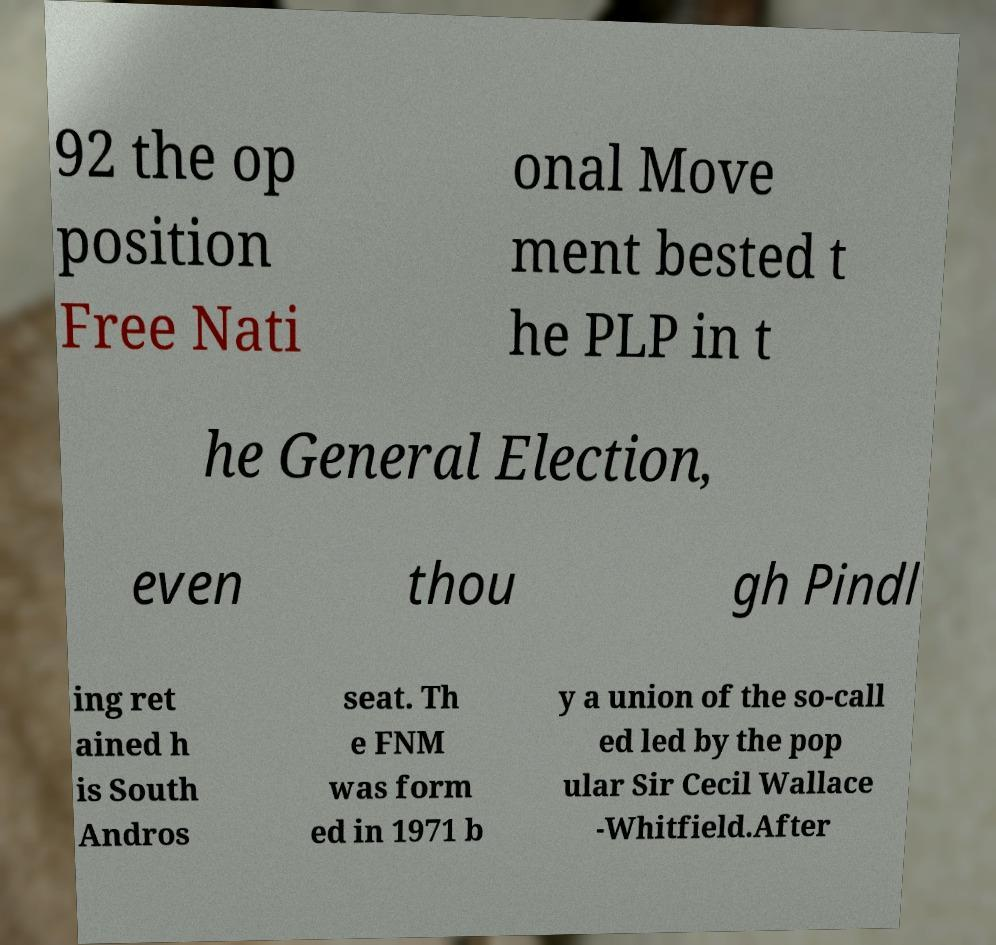Please read and relay the text visible in this image. What does it say? 92 the op position Free Nati onal Move ment bested t he PLP in t he General Election, even thou gh Pindl ing ret ained h is South Andros seat. Th e FNM was form ed in 1971 b y a union of the so-call ed led by the pop ular Sir Cecil Wallace -Whitfield.After 